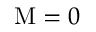<formula> <loc_0><loc_0><loc_500><loc_500>M = 0</formula> 